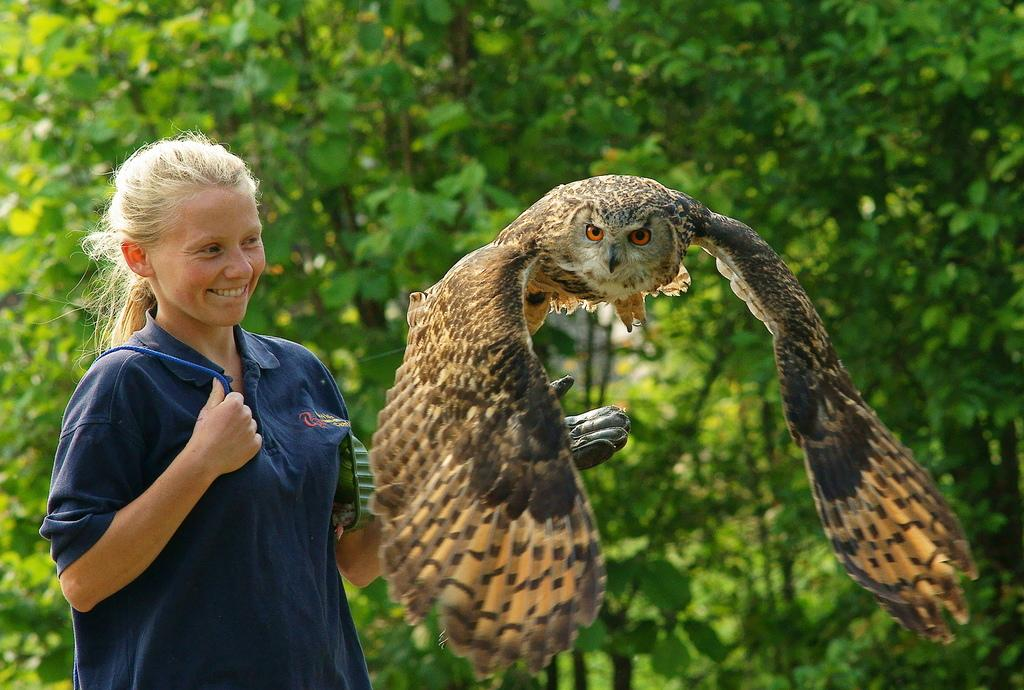Who is the main subject in the image? There is a lady in the image. What is the lady wearing on her hands? The lady is wearing gloves. What is the lady holding or carrying in the image? The lady is carrying an object. What can be seen in the background of the image? There are trees and an owl visible in the background of the image. What type of stocking is the lady wearing in the image? The lady is not wearing stockings in the image; she is wearing gloves. Can you describe the texture of the owl's feathers in the image? There is no mention of the owl's feathers or their texture in the provided facts, so we cannot answer this question. 